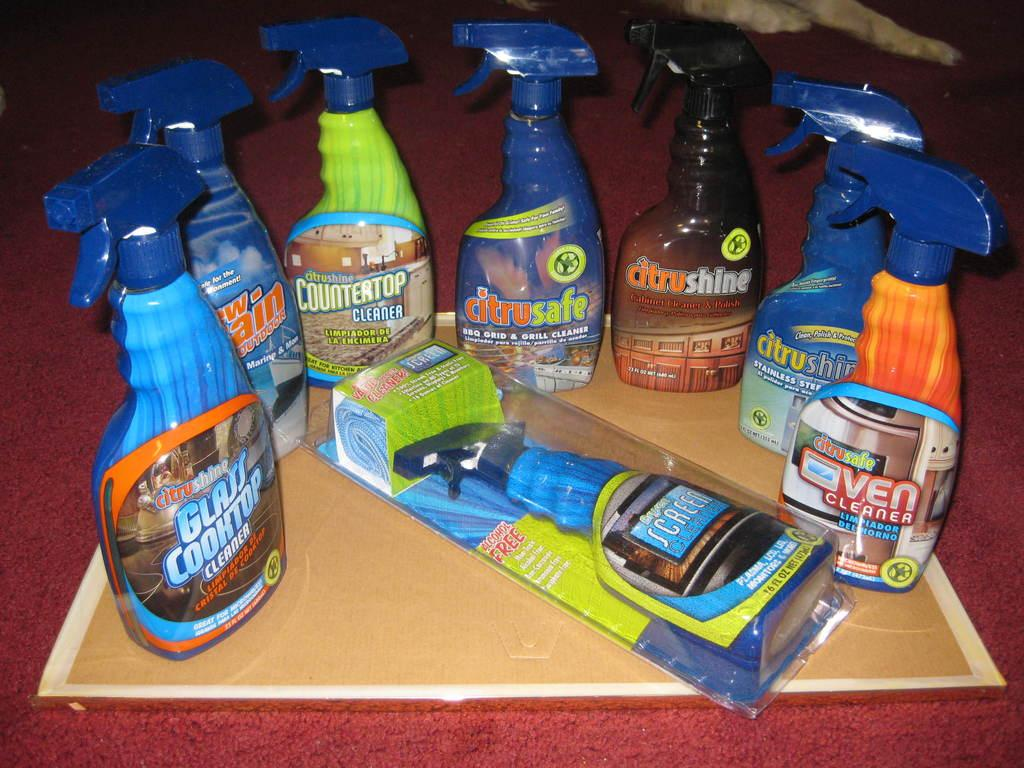<image>
Provide a brief description of the given image. Various bottles of cleaning solution, such as Glass Cooktop cleaner, Citrusafe Oven cleaner, among others. 